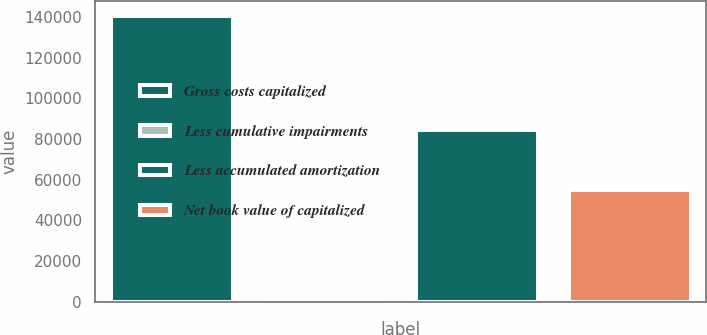<chart> <loc_0><loc_0><loc_500><loc_500><bar_chart><fcel>Gross costs capitalized<fcel>Less cumulative impairments<fcel>Less accumulated amortization<fcel>Net book value of capitalized<nl><fcel>140741<fcel>1156<fcel>84653<fcel>54932<nl></chart> 